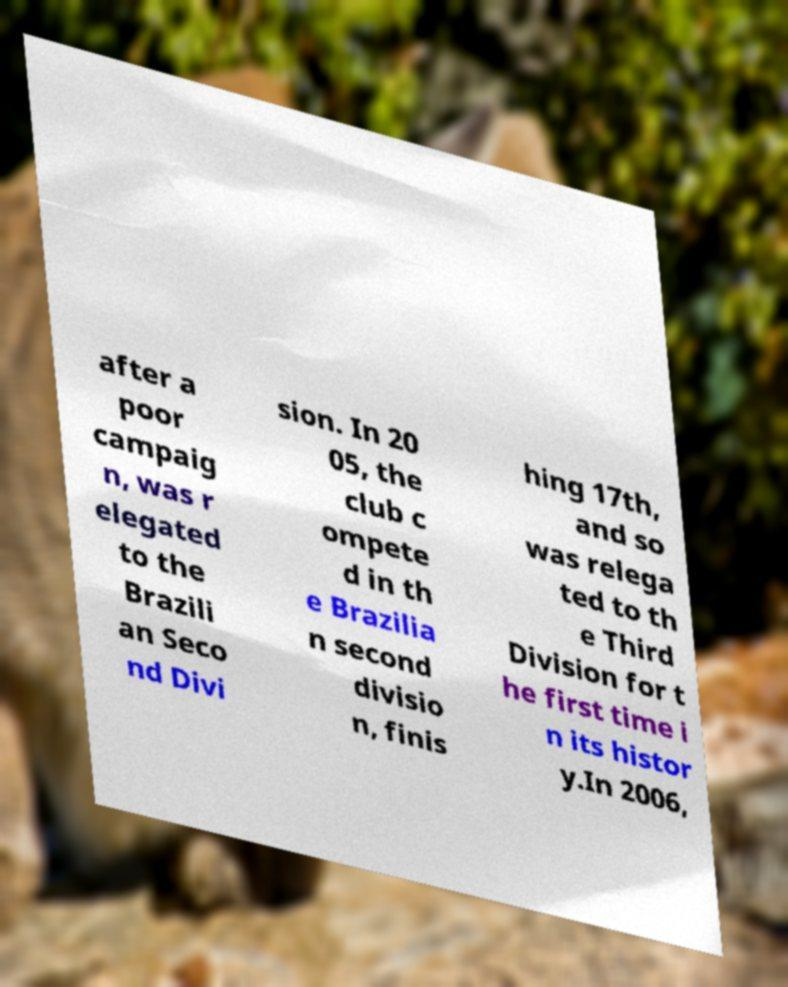Please identify and transcribe the text found in this image. after a poor campaig n, was r elegated to the Brazili an Seco nd Divi sion. In 20 05, the club c ompete d in th e Brazilia n second divisio n, finis hing 17th, and so was relega ted to th e Third Division for t he first time i n its histor y.In 2006, 